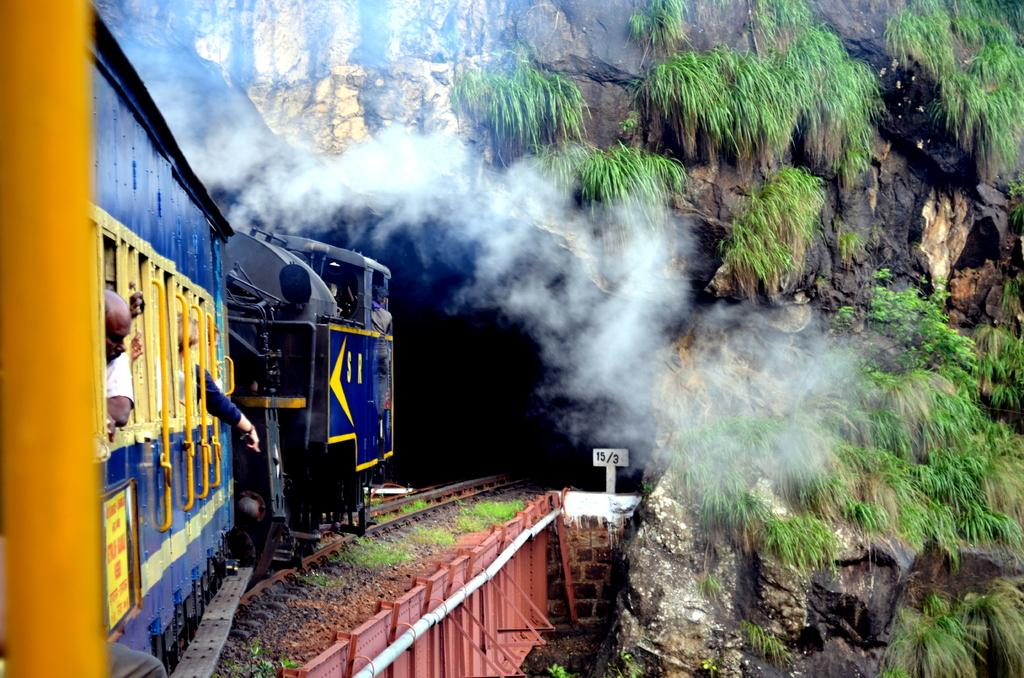What is the main subject of the image? The main subject of the image is a train. Where is the train located in the image? The train is on a railway track. What is the train doing in the image? The train is moving into a tunnel. What can be seen coming out of the train in the image? There is smoke visible in the image. What type of vegetation can be seen in the image? There is grass visible in the image. What holiday is being celebrated in the image? There is no indication of a holiday being celebrated in the image; it features a train moving into a tunnel. How many train cars are visible in the image? The provided facts do not specify the number of train cars visible in the image. 